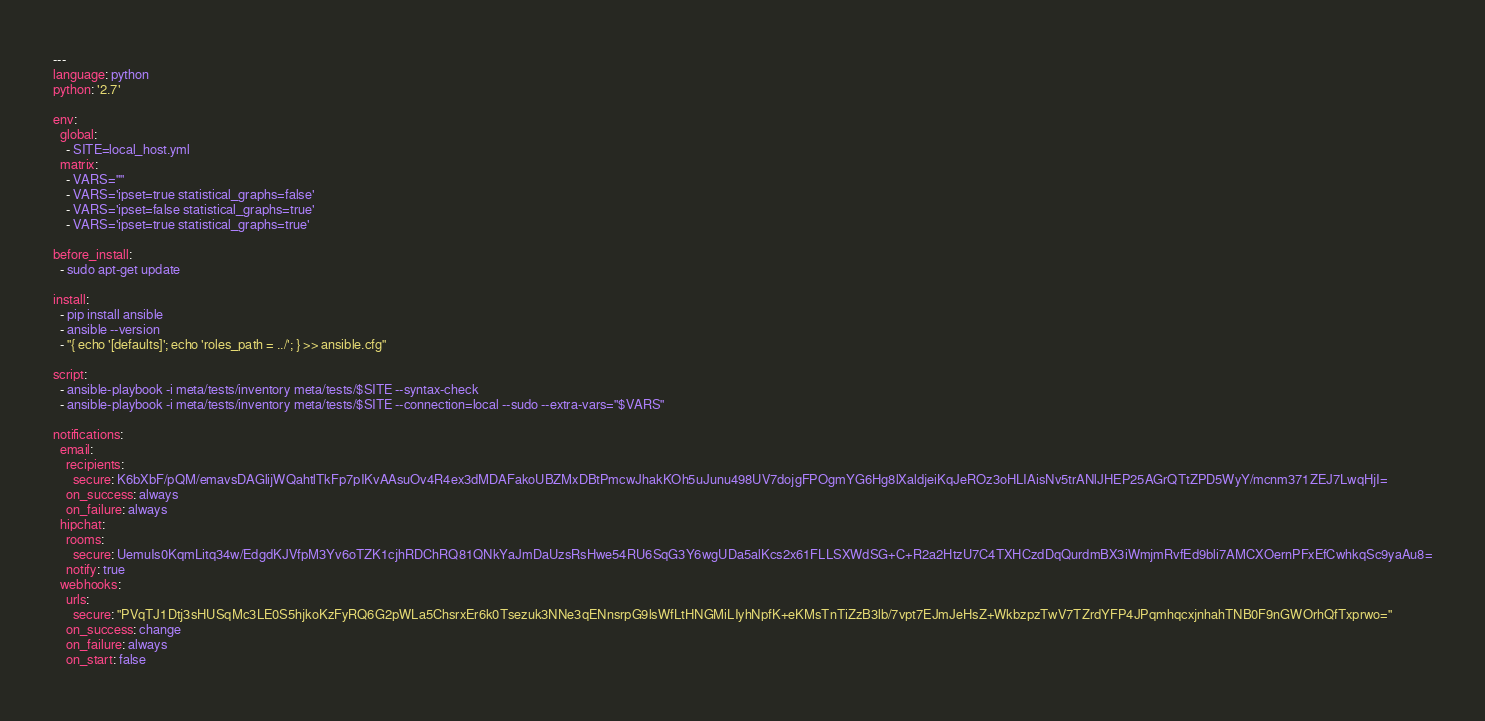<code> <loc_0><loc_0><loc_500><loc_500><_YAML_>---
language: python
python: '2.7'

env:
  global:
    - SITE=local_host.yml
  matrix:
    - VARS=""
    - VARS='ipset=true statistical_graphs=false'
    - VARS='ipset=false statistical_graphs=true'
    - VARS='ipset=true statistical_graphs=true'

before_install:
  - sudo apt-get update

install:
  - pip install ansible
  - ansible --version
  - "{ echo '[defaults]'; echo 'roles_path = ../'; } >> ansible.cfg"

script:
  - ansible-playbook -i meta/tests/inventory meta/tests/$SITE --syntax-check
  - ansible-playbook -i meta/tests/inventory meta/tests/$SITE --connection=local --sudo --extra-vars="$VARS"

notifications:
  email:
    recipients:
      secure: K6bXbF/pQM/emavsDAGlijWQahtlTkFp7pIKvAAsuOv4R4ex3dMDAFakoUBZMxDBtPmcwJhakKOh5uJunu498UV7dojgFPOgmYG6Hg8lXaldjeiKqJeROz3oHLIAisNv5trANlJHEP25AGrQTtZPD5WyY/mcnm371ZEJ7LwqHjI=
    on_success: always
    on_failure: always
  hipchat:
    rooms:
      secure: UemuIs0KqmLitq34w/EdgdKJVfpM3Yv6oTZK1cjhRDChRQ81QNkYaJmDaUzsRsHwe54RU6SqG3Y6wgUDa5alKcs2x61FLLSXWdSG+C+R2a2HtzU7C4TXHCzdDqQurdmBX3iWmjmRvfEd9bli7AMCXOernPFxEfCwhkqSc9yaAu8=
    notify: true
  webhooks:
    urls:
      secure: "PVqTJ1Dtj3sHUSqMc3LE0S5hjkoKzFyRQ6G2pWLa5ChsrxEr6k0Tsezuk3NNe3qENnsrpG9lsWfLtHNGMiLIyhNpfK+eKMsTnTiZzB3lb/7vpt7EJmJeHsZ+WkbzpzTwV7TZrdYFP4JPqmhqcxjnhahTNB0F9nGWOrhQfTxprwo="
    on_success: change 
    on_failure: always 
    on_start: false 
</code> 